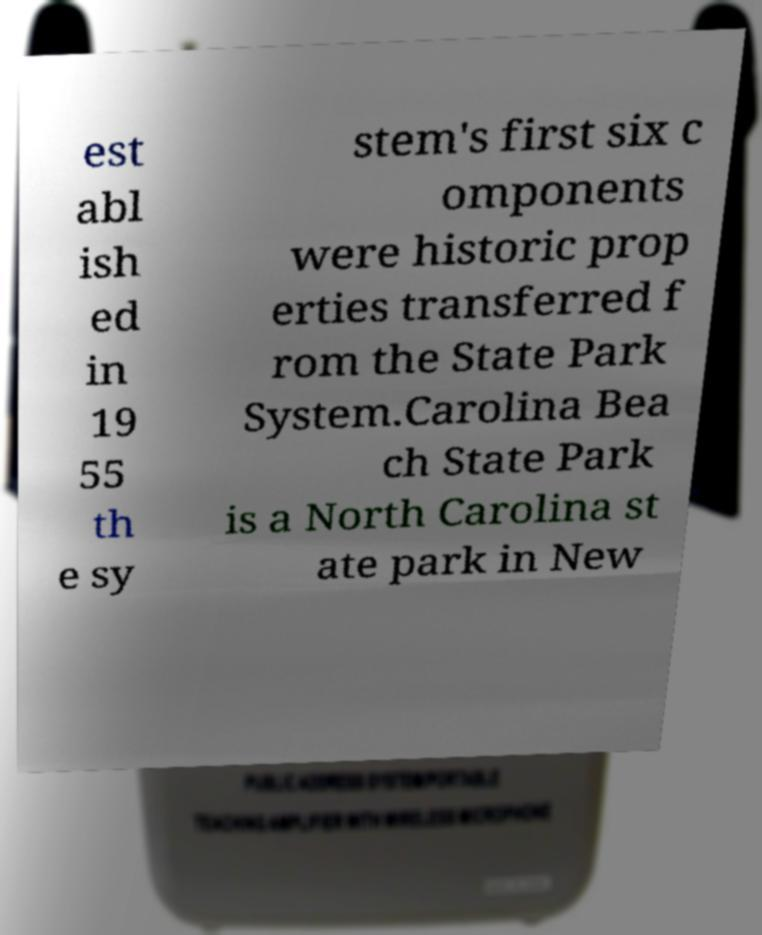Can you read and provide the text displayed in the image?This photo seems to have some interesting text. Can you extract and type it out for me? est abl ish ed in 19 55 th e sy stem's first six c omponents were historic prop erties transferred f rom the State Park System.Carolina Bea ch State Park is a North Carolina st ate park in New 